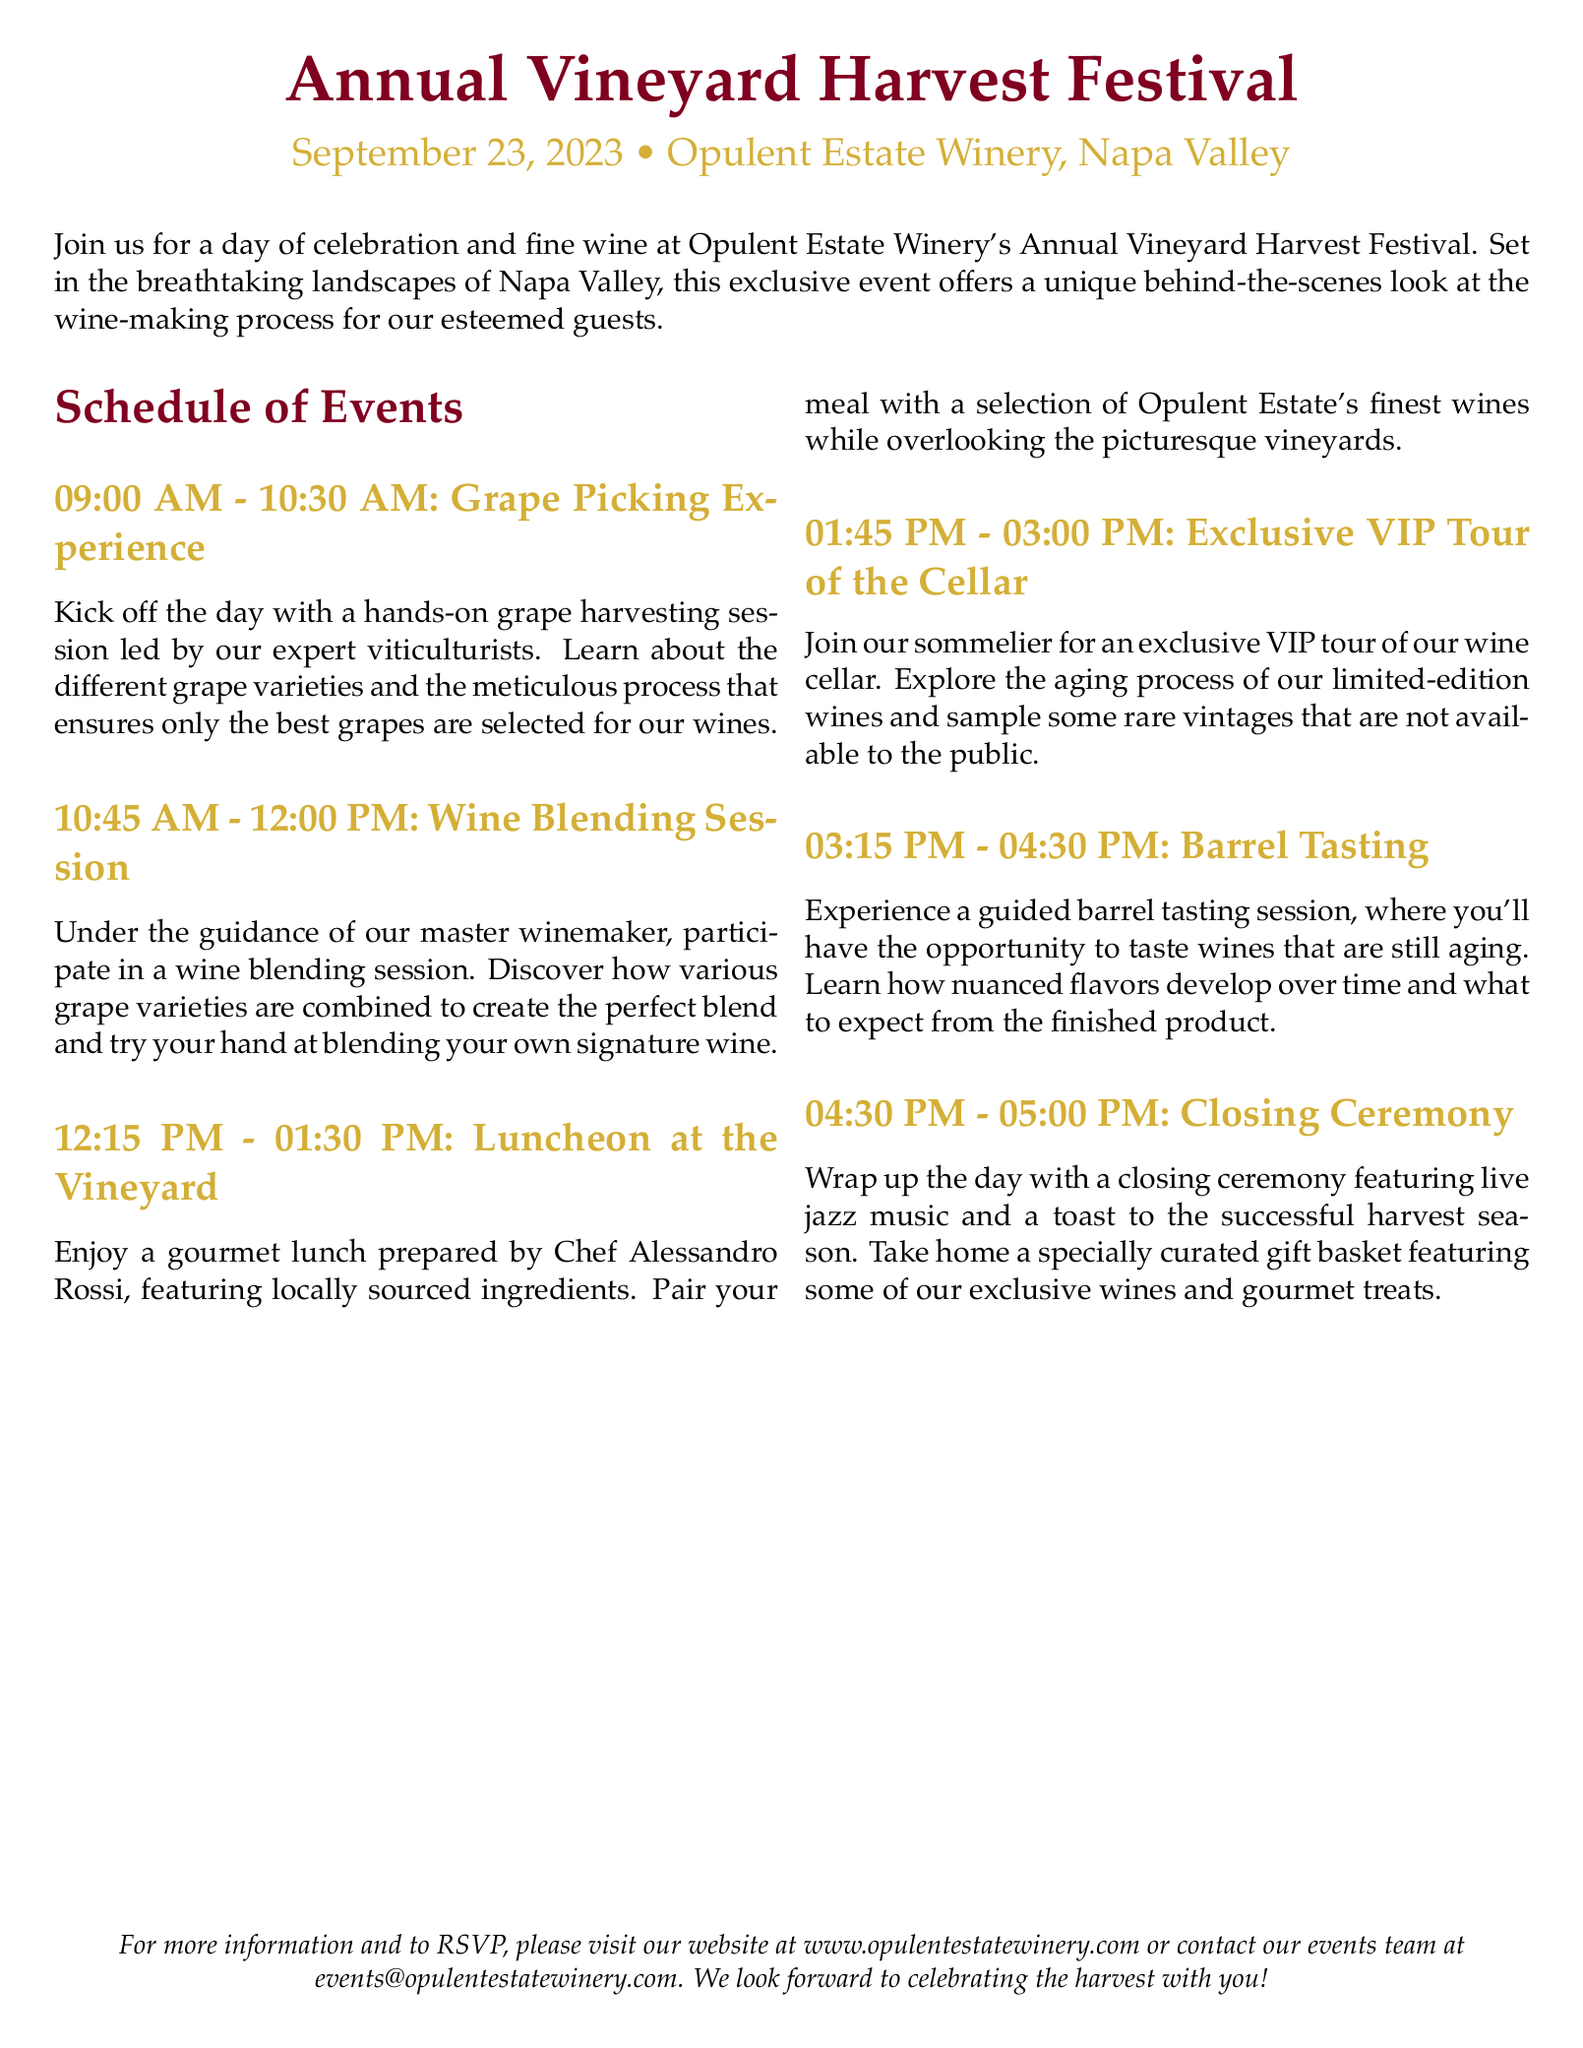what is the date of the festival? The document states the event date as September 23, 2023.
Answer: September 23, 2023 where is the festival held? The festival is hosted at Opulent Estate Winery in Napa Valley.
Answer: Opulent Estate Winery, Napa Valley what is the last event of the day? The final event listed is the Closing Ceremony.
Answer: Closing Ceremony how long is the wine blending session? The duration of the wine blending session is specified as 1 hour and 15 minutes.
Answer: 1 hour and 15 minutes who prepares the lunch for the event? The document mentions Chef Alessandro Rossi as the chef preparing the lunch.
Answer: Chef Alessandro Rossi what activity follows the grape picking experience? The event that follows is the Wine Blending Session.
Answer: Wine Blending Session what type of music will feature during the closing ceremony? The closing ceremony includes live jazz music.
Answer: live jazz music how many main events are scheduled before the closing ceremony? There are five main events before the closing ceremony.
Answer: five 